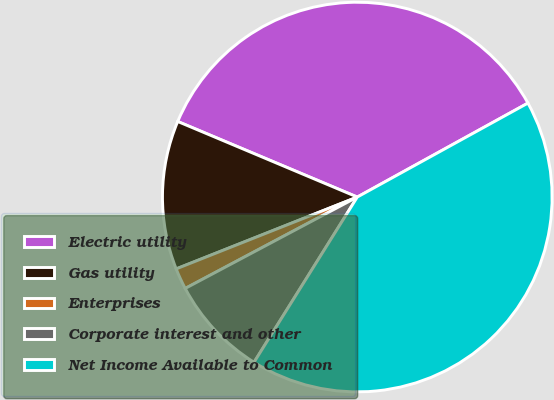Convert chart to OTSL. <chart><loc_0><loc_0><loc_500><loc_500><pie_chart><fcel>Electric utility<fcel>Gas utility<fcel>Enterprises<fcel>Corporate interest and other<fcel>Net Income Available to Common<nl><fcel>35.65%<fcel>12.35%<fcel>1.76%<fcel>8.34%<fcel>41.9%<nl></chart> 